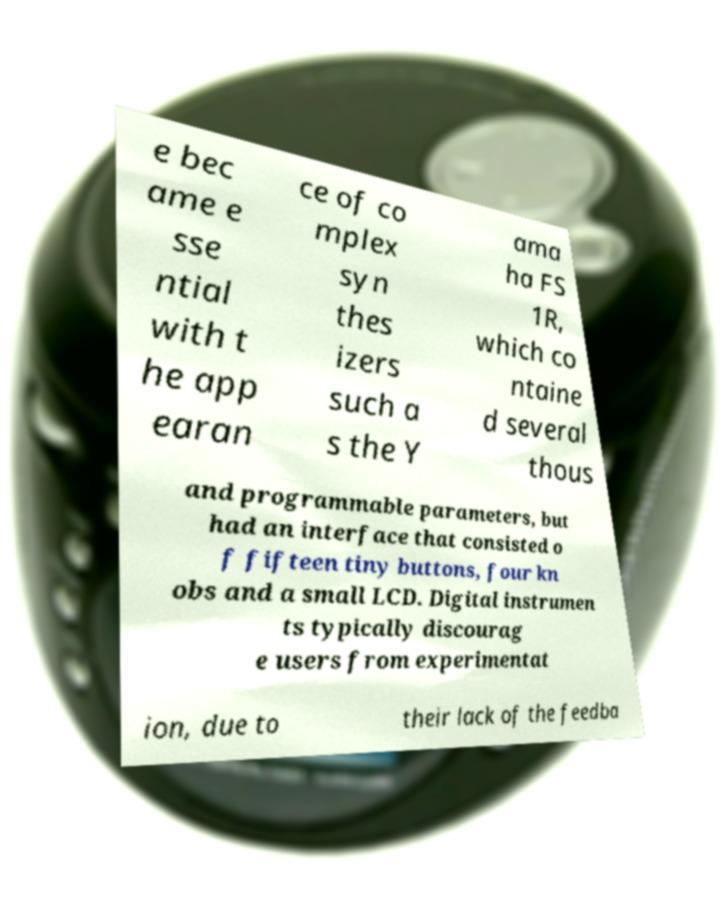I need the written content from this picture converted into text. Can you do that? e bec ame e sse ntial with t he app earan ce of co mplex syn thes izers such a s the Y ama ha FS 1R, which co ntaine d several thous and programmable parameters, but had an interface that consisted o f fifteen tiny buttons, four kn obs and a small LCD. Digital instrumen ts typically discourag e users from experimentat ion, due to their lack of the feedba 